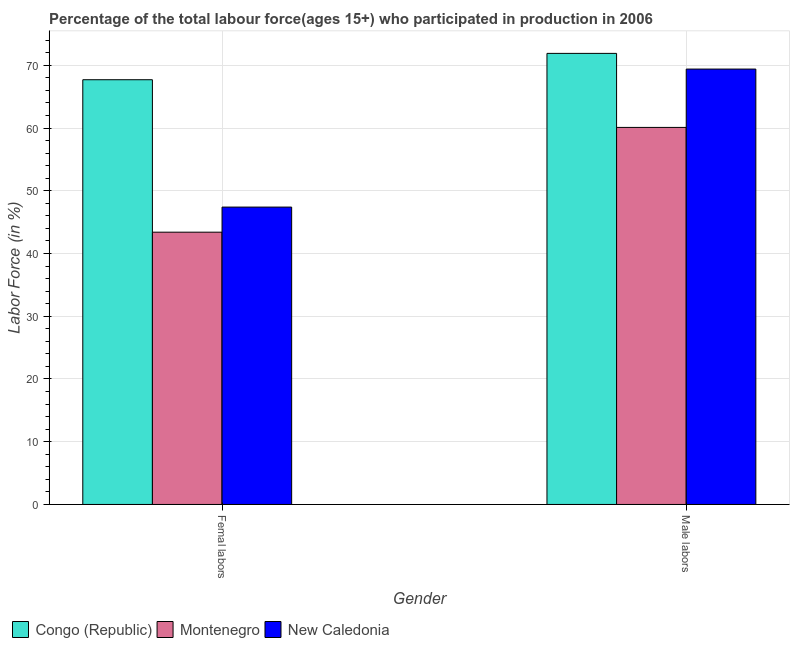Are the number of bars per tick equal to the number of legend labels?
Keep it short and to the point. Yes. Are the number of bars on each tick of the X-axis equal?
Offer a terse response. Yes. How many bars are there on the 1st tick from the left?
Provide a short and direct response. 3. What is the label of the 2nd group of bars from the left?
Your answer should be compact. Male labors. What is the percentage of female labor force in New Caledonia?
Offer a terse response. 47.4. Across all countries, what is the maximum percentage of female labor force?
Ensure brevity in your answer.  67.7. Across all countries, what is the minimum percentage of female labor force?
Offer a very short reply. 43.4. In which country was the percentage of male labour force maximum?
Your answer should be very brief. Congo (Republic). In which country was the percentage of male labour force minimum?
Make the answer very short. Montenegro. What is the total percentage of female labor force in the graph?
Make the answer very short. 158.5. What is the difference between the percentage of male labour force in Congo (Republic) and that in Montenegro?
Your answer should be compact. 11.8. What is the difference between the percentage of male labour force in Montenegro and the percentage of female labor force in New Caledonia?
Your answer should be compact. 12.7. What is the average percentage of female labor force per country?
Your answer should be compact. 52.83. What is the difference between the percentage of female labor force and percentage of male labour force in Montenegro?
Offer a terse response. -16.7. In how many countries, is the percentage of male labour force greater than 66 %?
Your response must be concise. 2. What is the ratio of the percentage of male labour force in Congo (Republic) to that in New Caledonia?
Keep it short and to the point. 1.04. Is the percentage of female labor force in Montenegro less than that in New Caledonia?
Offer a very short reply. Yes. What does the 3rd bar from the left in Male labors represents?
Make the answer very short. New Caledonia. What does the 2nd bar from the right in Male labors represents?
Keep it short and to the point. Montenegro. What is the difference between two consecutive major ticks on the Y-axis?
Offer a very short reply. 10. Does the graph contain grids?
Your answer should be compact. Yes. Where does the legend appear in the graph?
Make the answer very short. Bottom left. How many legend labels are there?
Keep it short and to the point. 3. How are the legend labels stacked?
Your answer should be compact. Horizontal. What is the title of the graph?
Your answer should be very brief. Percentage of the total labour force(ages 15+) who participated in production in 2006. What is the label or title of the X-axis?
Your answer should be compact. Gender. What is the label or title of the Y-axis?
Keep it short and to the point. Labor Force (in %). What is the Labor Force (in %) of Congo (Republic) in Femal labors?
Provide a short and direct response. 67.7. What is the Labor Force (in %) of Montenegro in Femal labors?
Give a very brief answer. 43.4. What is the Labor Force (in %) of New Caledonia in Femal labors?
Keep it short and to the point. 47.4. What is the Labor Force (in %) of Congo (Republic) in Male labors?
Ensure brevity in your answer.  71.9. What is the Labor Force (in %) of Montenegro in Male labors?
Provide a succinct answer. 60.1. What is the Labor Force (in %) in New Caledonia in Male labors?
Ensure brevity in your answer.  69.4. Across all Gender, what is the maximum Labor Force (in %) of Congo (Republic)?
Keep it short and to the point. 71.9. Across all Gender, what is the maximum Labor Force (in %) of Montenegro?
Provide a short and direct response. 60.1. Across all Gender, what is the maximum Labor Force (in %) of New Caledonia?
Offer a terse response. 69.4. Across all Gender, what is the minimum Labor Force (in %) in Congo (Republic)?
Give a very brief answer. 67.7. Across all Gender, what is the minimum Labor Force (in %) of Montenegro?
Ensure brevity in your answer.  43.4. Across all Gender, what is the minimum Labor Force (in %) in New Caledonia?
Make the answer very short. 47.4. What is the total Labor Force (in %) of Congo (Republic) in the graph?
Offer a terse response. 139.6. What is the total Labor Force (in %) of Montenegro in the graph?
Provide a short and direct response. 103.5. What is the total Labor Force (in %) in New Caledonia in the graph?
Ensure brevity in your answer.  116.8. What is the difference between the Labor Force (in %) of Congo (Republic) in Femal labors and that in Male labors?
Offer a terse response. -4.2. What is the difference between the Labor Force (in %) in Montenegro in Femal labors and that in Male labors?
Keep it short and to the point. -16.7. What is the difference between the Labor Force (in %) of Montenegro in Femal labors and the Labor Force (in %) of New Caledonia in Male labors?
Ensure brevity in your answer.  -26. What is the average Labor Force (in %) of Congo (Republic) per Gender?
Provide a succinct answer. 69.8. What is the average Labor Force (in %) in Montenegro per Gender?
Make the answer very short. 51.75. What is the average Labor Force (in %) of New Caledonia per Gender?
Your response must be concise. 58.4. What is the difference between the Labor Force (in %) in Congo (Republic) and Labor Force (in %) in Montenegro in Femal labors?
Give a very brief answer. 24.3. What is the difference between the Labor Force (in %) of Congo (Republic) and Labor Force (in %) of New Caledonia in Femal labors?
Ensure brevity in your answer.  20.3. What is the difference between the Labor Force (in %) in Congo (Republic) and Labor Force (in %) in Montenegro in Male labors?
Provide a succinct answer. 11.8. What is the difference between the Labor Force (in %) of Congo (Republic) and Labor Force (in %) of New Caledonia in Male labors?
Offer a terse response. 2.5. What is the ratio of the Labor Force (in %) in Congo (Republic) in Femal labors to that in Male labors?
Provide a succinct answer. 0.94. What is the ratio of the Labor Force (in %) of Montenegro in Femal labors to that in Male labors?
Provide a succinct answer. 0.72. What is the ratio of the Labor Force (in %) of New Caledonia in Femal labors to that in Male labors?
Your answer should be compact. 0.68. What is the difference between the highest and the lowest Labor Force (in %) of Congo (Republic)?
Give a very brief answer. 4.2. 